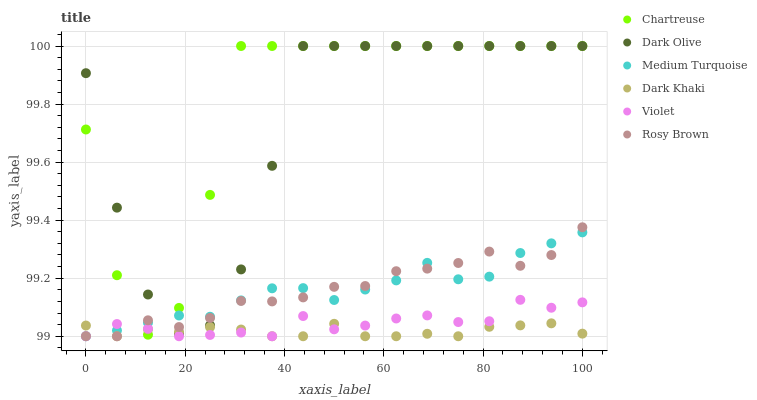Does Dark Khaki have the minimum area under the curve?
Answer yes or no. Yes. Does Chartreuse have the maximum area under the curve?
Answer yes or no. Yes. Does Dark Olive have the minimum area under the curve?
Answer yes or no. No. Does Dark Olive have the maximum area under the curve?
Answer yes or no. No. Is Dark Khaki the smoothest?
Answer yes or no. Yes. Is Chartreuse the roughest?
Answer yes or no. Yes. Is Dark Olive the smoothest?
Answer yes or no. No. Is Dark Olive the roughest?
Answer yes or no. No. Does Rosy Brown have the lowest value?
Answer yes or no. Yes. Does Dark Olive have the lowest value?
Answer yes or no. No. Does Chartreuse have the highest value?
Answer yes or no. Yes. Does Dark Khaki have the highest value?
Answer yes or no. No. Is Violet less than Dark Olive?
Answer yes or no. Yes. Is Dark Olive greater than Violet?
Answer yes or no. Yes. Does Dark Olive intersect Chartreuse?
Answer yes or no. Yes. Is Dark Olive less than Chartreuse?
Answer yes or no. No. Is Dark Olive greater than Chartreuse?
Answer yes or no. No. Does Violet intersect Dark Olive?
Answer yes or no. No. 